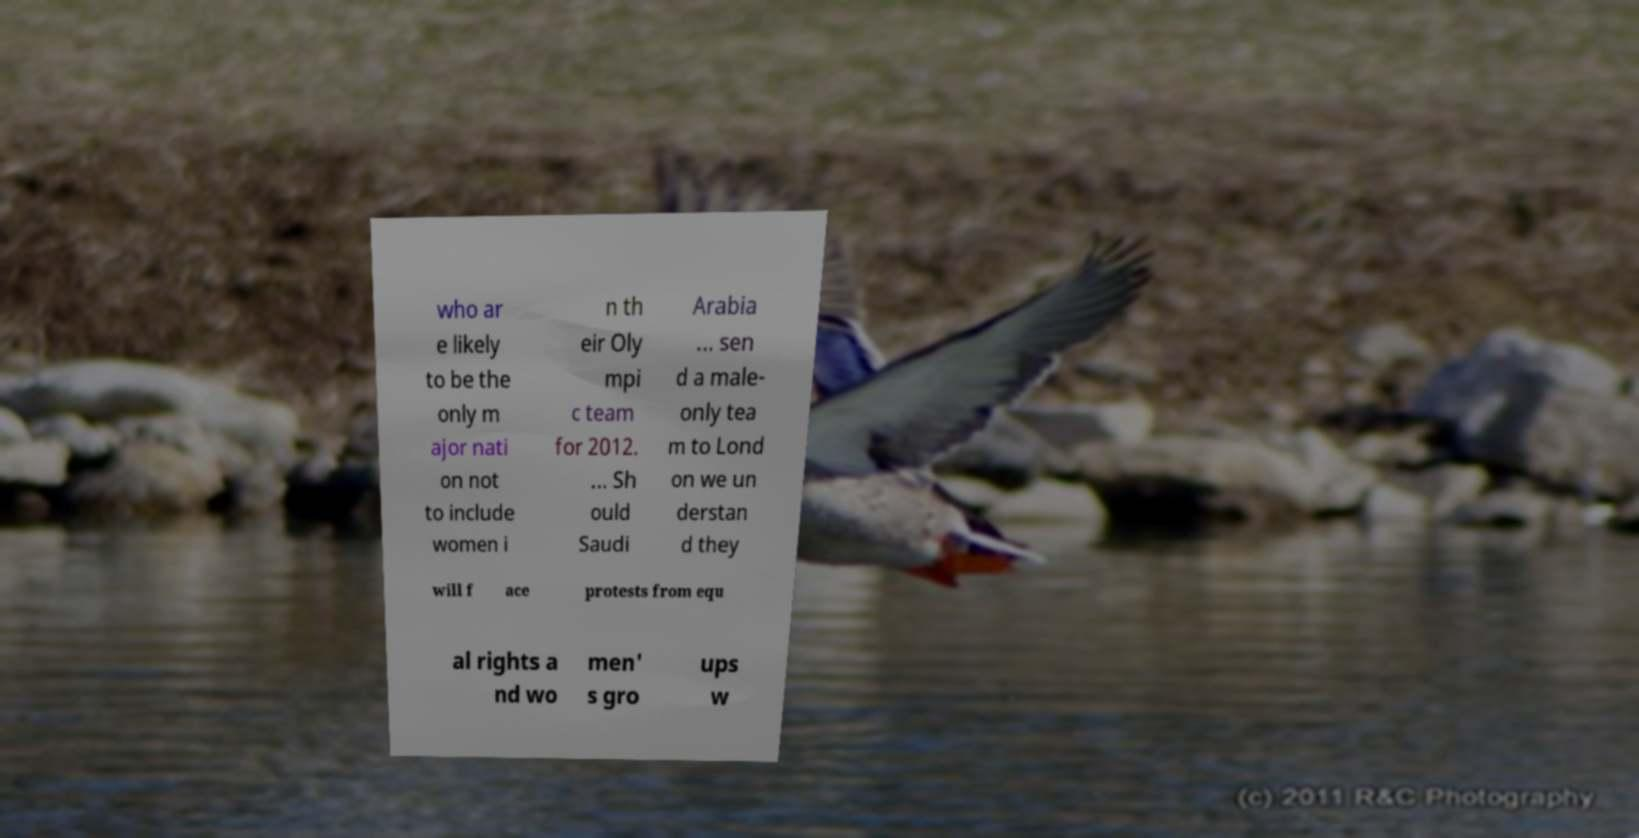Can you read and provide the text displayed in the image?This photo seems to have some interesting text. Can you extract and type it out for me? who ar e likely to be the only m ajor nati on not to include women i n th eir Oly mpi c team for 2012. ... Sh ould Saudi Arabia ... sen d a male- only tea m to Lond on we un derstan d they will f ace protests from equ al rights a nd wo men' s gro ups w 